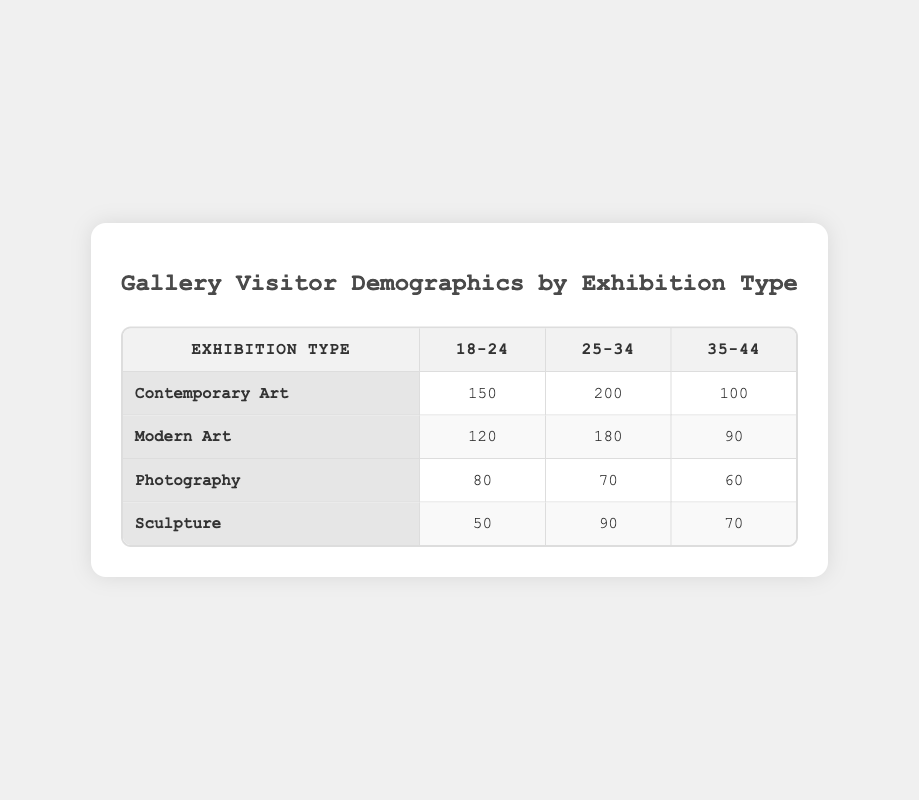What is the visitor count for the Contemporary Art exhibition in the age group 25-34? The table shows that for the Contemporary Art exhibition, the visitor count in the age group 25-34 is directly listed as 200.
Answer: 200 Which exhibition type has the highest visitor count for the age group 18-24? By looking at the table, the visitor counts for age group 18-24 are: Contemporary Art: 150, Modern Art: 120, Photography: 80, and Sculpture: 50. The highest count is from Contemporary Art with 150 visitors.
Answer: Contemporary Art Is the visitor count for Sculpture among the 35-44 age group greater than that for Photography in the same age group? The visitor count for Sculpture in the 35-44 age group is 70, while for Photography it is 60. Since 70 is greater than 60, the statement is true.
Answer: Yes What is the total visitor count for the Modern Art exhibition across all age groups? To find the total visitor count for Modern Art, we add up the counts for all age groups: 120 (18-24) + 180 (25-34) + 90 (35-44) = 390.
Answer: 390 Which age group has the least number of visitors across all exhibition types? The age group visitor counts are as follows: 18-24: 150 + 120 + 80 + 50 = 400; 25-34: 200 + 180 + 70 + 90 = 540; 35-44: 100 + 90 + 60 + 70 = 320. The least number is in the 35-44 age group with 320 visitors.
Answer: 35-44 Is there any exhibition type where all age groups have the same visitor count? The table shows varying visitor counts for each age group within all exhibition types. Thus, there is no exhibition type where all age groups have the same count.
Answer: No What is the average visitor count for the age group 25-34? For age group 25-34, the visitor counts are: 200 (Contemporary Art) + 180 (Modern Art) + 70 (Photography) + 90 (Sculpture) = 540. There are 4 exhibition types, so the average is 540 / 4 = 135.
Answer: 135 Which exhibition type had the lowest total visitor count? Calculating the totals: Contemporary Art: 450, Modern Art: 390, Photography: 210, Sculpture: 210. The lowest is Photography and Sculpture, both with 210 visitors.
Answer: Photography and Sculpture What is the difference in visitor count between the age group 18-24 for Contemporary Art and Sculpture? The counts are 150 for Contemporary Art and 50 for Sculpture. The difference is 150 - 50 = 100.
Answer: 100 